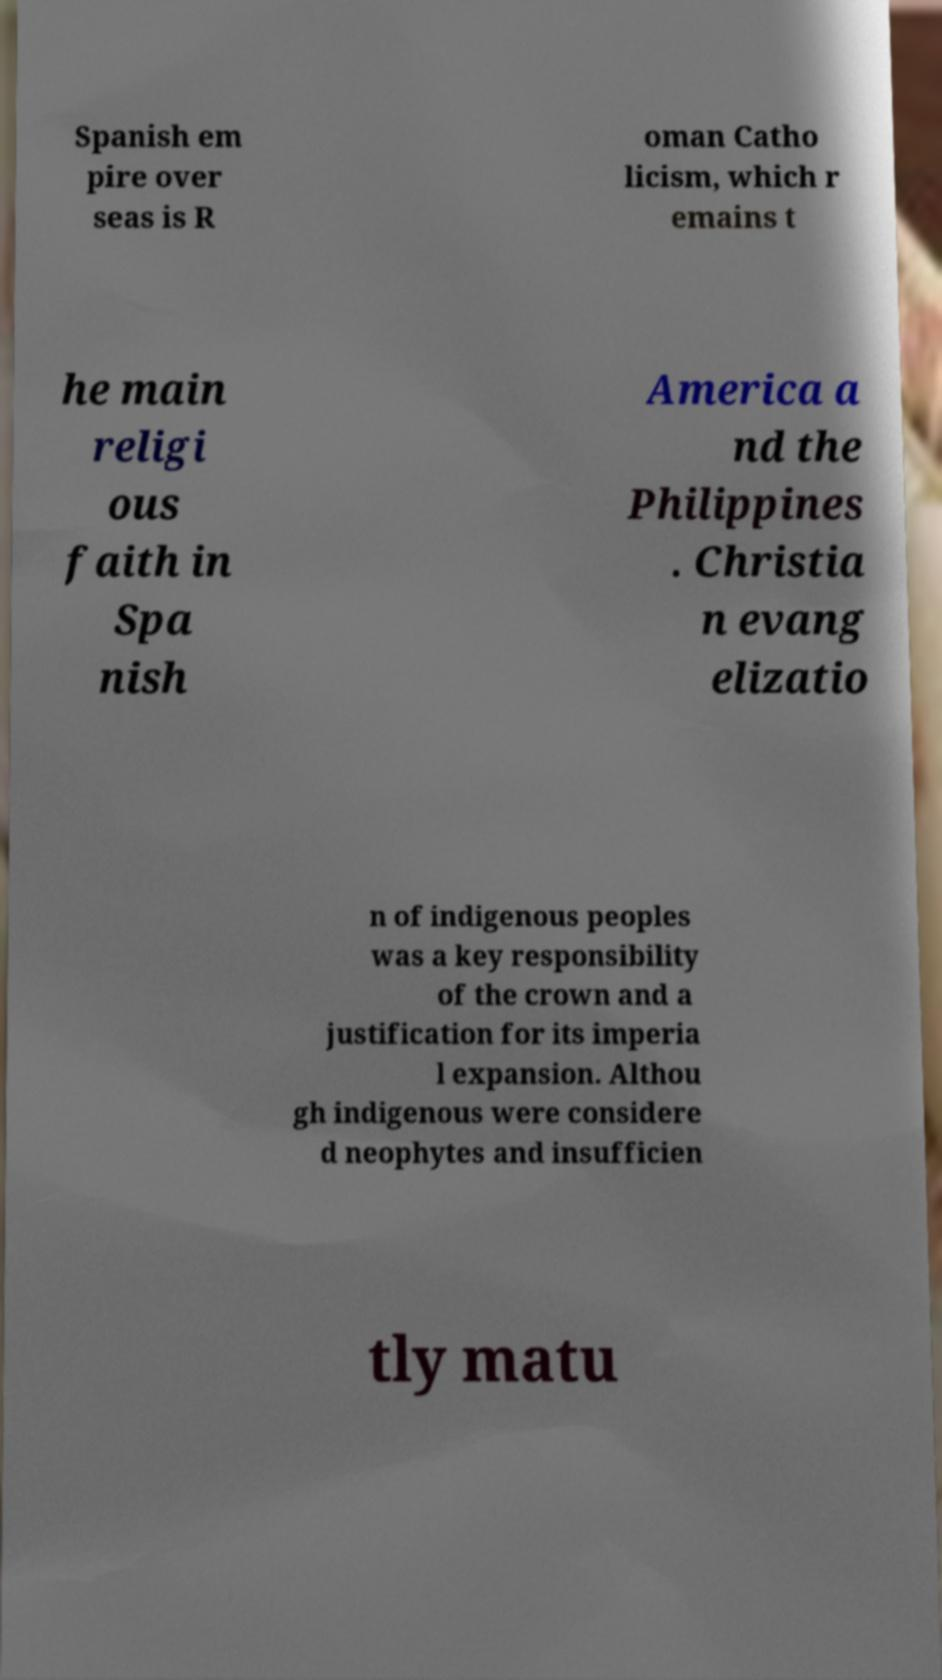Could you assist in decoding the text presented in this image and type it out clearly? Spanish em pire over seas is R oman Catho licism, which r emains t he main religi ous faith in Spa nish America a nd the Philippines . Christia n evang elizatio n of indigenous peoples was a key responsibility of the crown and a justification for its imperia l expansion. Althou gh indigenous were considere d neophytes and insufficien tly matu 